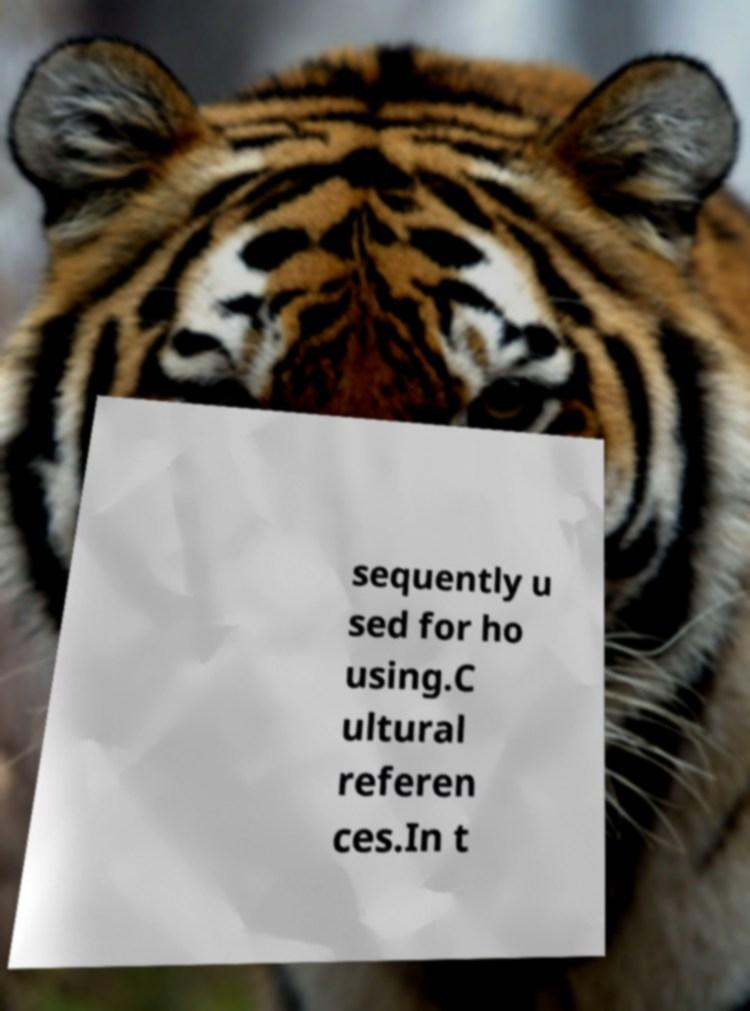Can you read and provide the text displayed in the image?This photo seems to have some interesting text. Can you extract and type it out for me? sequently u sed for ho using.C ultural referen ces.In t 